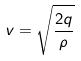<formula> <loc_0><loc_0><loc_500><loc_500>v = \sqrt { \frac { 2 q } { \rho } }</formula> 